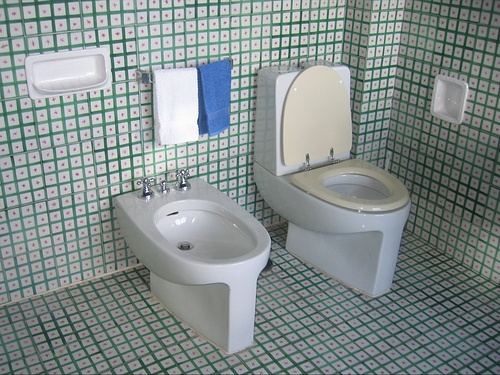Describe the objects in this image and their specific colors. I can see toilet in darkgray, gray, and lightgray tones and toilet in darkgray, lightgray, and gray tones in this image. 